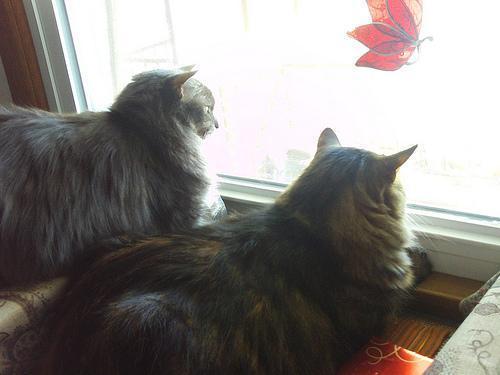How many cats are in this photo?
Give a very brief answer. 2. 